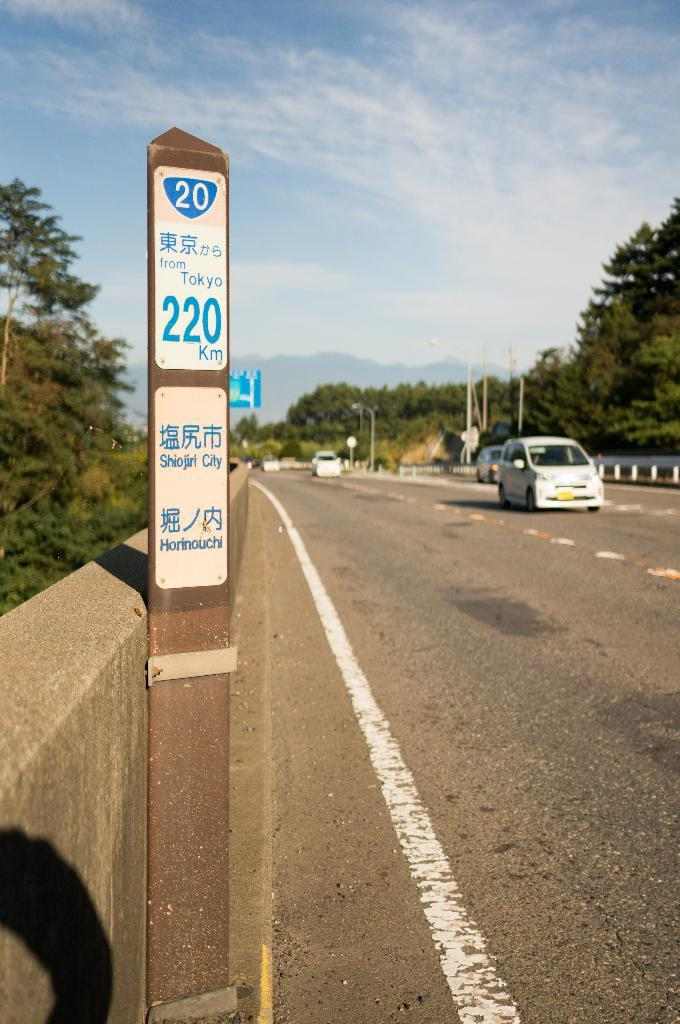<image>
Describe the image concisely. A pole with the number 20 on it that says 220km further down. 